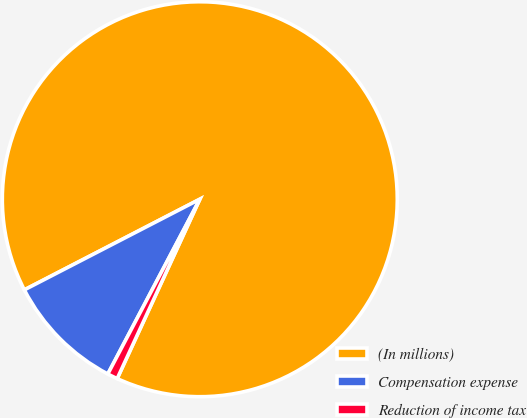<chart> <loc_0><loc_0><loc_500><loc_500><pie_chart><fcel>(In millions)<fcel>Compensation expense<fcel>Reduction of income tax<nl><fcel>89.45%<fcel>9.7%<fcel>0.84%<nl></chart> 